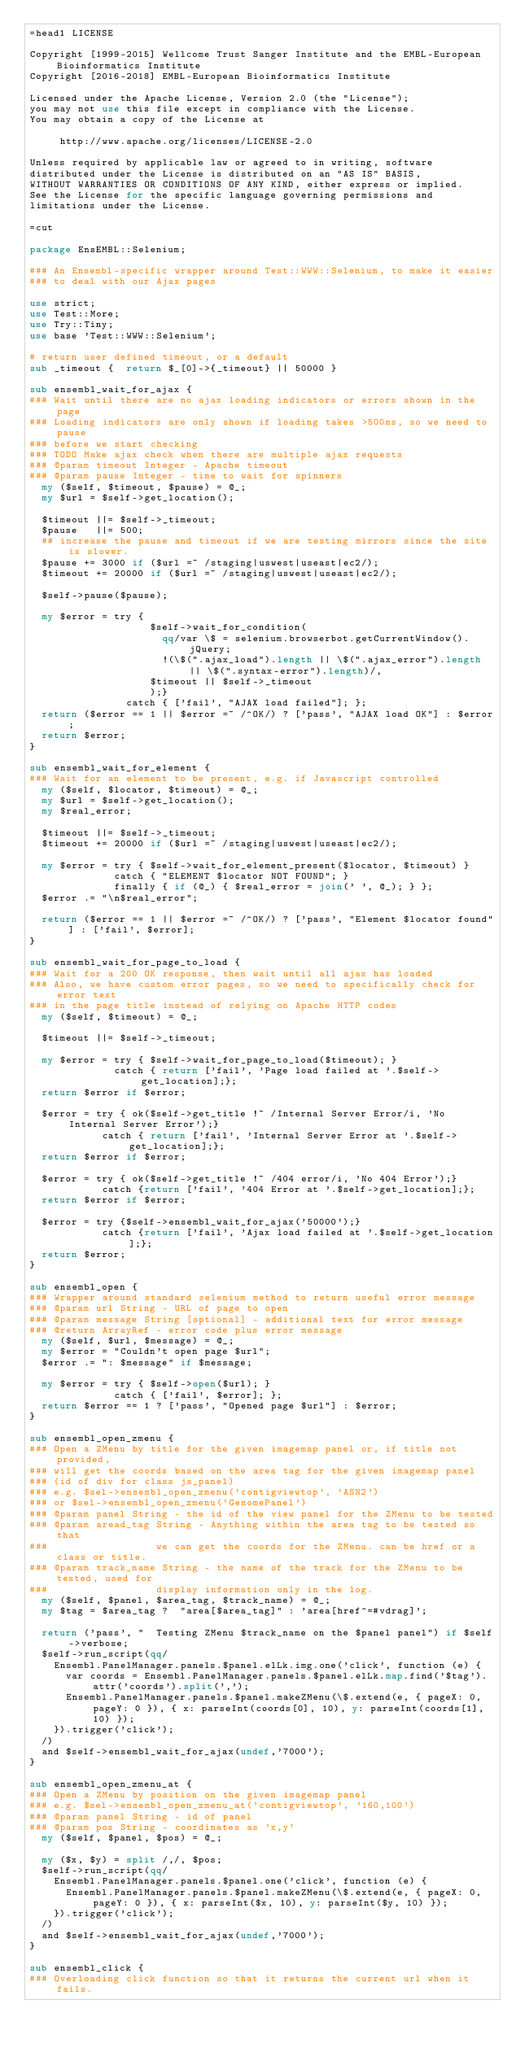Convert code to text. <code><loc_0><loc_0><loc_500><loc_500><_Perl_>=head1 LICENSE

Copyright [1999-2015] Wellcome Trust Sanger Institute and the EMBL-European Bioinformatics Institute
Copyright [2016-2018] EMBL-European Bioinformatics Institute

Licensed under the Apache License, Version 2.0 (the "License");
you may not use this file except in compliance with the License.
You may obtain a copy of the License at

     http://www.apache.org/licenses/LICENSE-2.0

Unless required by applicable law or agreed to in writing, software
distributed under the License is distributed on an "AS IS" BASIS,
WITHOUT WARRANTIES OR CONDITIONS OF ANY KIND, either express or implied.
See the License for the specific language governing permissions and
limitations under the License.

=cut

package EnsEMBL::Selenium;

### An Ensembl-specific wrapper around Test::WWW::Selenium, to make it easier
### to deal with our Ajax pages

use strict;
use Test::More;
use Try::Tiny;
use base 'Test::WWW::Selenium';

# return user defined timeout, or a default
sub _timeout {  return $_[0]->{_timeout} || 50000 }

sub ensembl_wait_for_ajax {
### Wait until there are no ajax loading indicators or errors shown in the page
### Loading indicators are only shown if loading takes >500ms, so we need to pause 
### before we start checking
### TODO Make ajax check when there are multiple ajax requests
### @param timeout Integer - Apache timeout
### @param pause Integer - time to wait for spinners
  my ($self, $timeout, $pause) = @_;
  my $url = $self->get_location();
  
  $timeout ||= $self->_timeout;
  $pause   ||= 500;
  ## increase the pause and timeout if we are testing mirrors since the site is slower.
  $pause += 3000 if ($url =~ /staging|uswest|useast|ec2/);
  $timeout += 20000 if ($url =~ /staging|uswest|useast|ec2/);

  $self->pause($pause);

  my $error = try {  
                    $self->wait_for_condition(
                      qq/var \$ = selenium.browserbot.getCurrentWindow().jQuery;
                      !(\$(".ajax_load").length || \$(".ajax_error").length || \$(".syntax-error").length)/,
                    $timeout || $self->_timeout
                    );}
                catch { ['fail', "AJAX load failed"]; };
  return ($error == 1 || $error =~ /^OK/) ? ['pass', "AJAX load OK"] : $error;
  return $error; 
}

sub ensembl_wait_for_element {
### Wait for an element to be present, e.g. if Javascript controlled
  my ($self, $locator, $timeout) = @_;
  my $url = $self->get_location();
  my $real_error;
 
  $timeout ||= $self->_timeout;
  $timeout += 20000 if ($url =~ /staging|uswest|useast|ec2/);

  my $error = try { $self->wait_for_element_present($locator, $timeout) }
              catch { "ELEMENT $locator NOT FOUND"; }
              finally { if (@_) { $real_error = join(' ', @_); } };
  $error .= "\n$real_error";

  return ($error == 1 || $error =~ /^OK/) ? ['pass', "Element $locator found"] : ['fail', $error];
}

sub ensembl_wait_for_page_to_load {
### Wait for a 200 OK response, then wait until all ajax has loaded
### Also, we have custom error pages, so we need to specifically check for error text 
### in the page title instead of relying on Apache HTTP codes 
  my ($self, $timeout) = @_;
  
  $timeout ||= $self->_timeout;

  my $error = try { $self->wait_for_page_to_load($timeout); }
              catch { return ['fail', 'Page load failed at '.$self->get_location];};
  return $error if $error;

  $error = try { ok($self->get_title !~ /Internal Server Error/i, 'No Internal Server Error');}
            catch { return ['fail', 'Internal Server Error at '.$self->get_location];};
  return $error if $error;

  $error = try { ok($self->get_title !~ /404 error/i, 'No 404 Error');}
            catch {return ['fail', '404 Error at '.$self->get_location];};
  return $error if $error;

  $error = try {$self->ensembl_wait_for_ajax('50000');}
            catch {return ['fail', 'Ajax load failed at '.$self->get_location];};
  return $error;
}

sub ensembl_open {
### Wrapper around standard selenium method to return useful error message 
### @param url String - URL of page to open
### @param message String [optional] - additional text for error message
### @return ArrayRef - error code plus error message
  my ($self, $url, $message) = @_;
  my $error = "Couldn't open page $url";
  $error .= ": $message" if $message; 
  
  my $error = try { $self->open($url); }
              catch { ['fail', $error]; };
  return $error == 1 ? ['pass', "Opened page $url"] : $error;
}

sub ensembl_open_zmenu {
### Open a ZMenu by title for the given imagemap panel or, if title not provided,
### will get the coords based on the area tag for the given imagemap panel 
### (id of div for class js_panel)
### e.g. $sel->ensembl_open_zmenu('contigviewtop', 'ASN2') 
### or $sel->ensembl_open_zmenu('GenomePanel')
### @param panel String - the id of the view panel for the ZMenu to be tested
### @param aread_tag String - Anything within the area tag to be tested so that 
###                  we can get the coords for the ZMenu. can be href or a class or title.
### @param track_name String - the name of the track for the ZMenu to be tested, used for 
###                  display information only in the log.
  my ($self, $panel, $area_tag, $track_name) = @_;
  my $tag = $area_tag ?  "area[$area_tag]" : 'area[href^=#vdrag]';  

  return ('pass', "  Testing ZMenu $track_name on the $panel panel") if $self->verbose;
  $self->run_script(qq/
    Ensembl.PanelManager.panels.$panel.elLk.img.one('click', function (e) {
      var coords = Ensembl.PanelManager.panels.$panel.elLk.map.find('$tag').attr('coords').split(','); 
      Ensembl.PanelManager.panels.$panel.makeZMenu(\$.extend(e, { pageX: 0, pageY: 0 }), { x: parseInt(coords[0], 10), y: parseInt(coords[1], 10) });
    }).trigger('click');
  /)
  and $self->ensembl_wait_for_ajax(undef,'7000');
}

sub ensembl_open_zmenu_at {
### Open a ZMenu by position on the given imagemap panel
### e.g. $sel->ensembl_open_zmenu_at('contigviewtop', '160,100')
### @param panel String - id of panel
### @param pos String - coordinates as 'x,y'
  my ($self, $panel, $pos) = @_;
  
  my ($x, $y) = split /,/, $pos;
  $self->run_script(qq/
    Ensembl.PanelManager.panels.$panel.one('click', function (e) {
      Ensembl.PanelManager.panels.$panel.makeZMenu(\$.extend(e, { pageX: 0, pageY: 0 }), { x: parseInt($x, 10), y: parseInt($y, 10) });
    }).trigger('click');
  /)
  and $self->ensembl_wait_for_ajax(undef,'7000');
}

sub ensembl_click {
### Overloading click function so that it returns the current url when it fails. </code> 